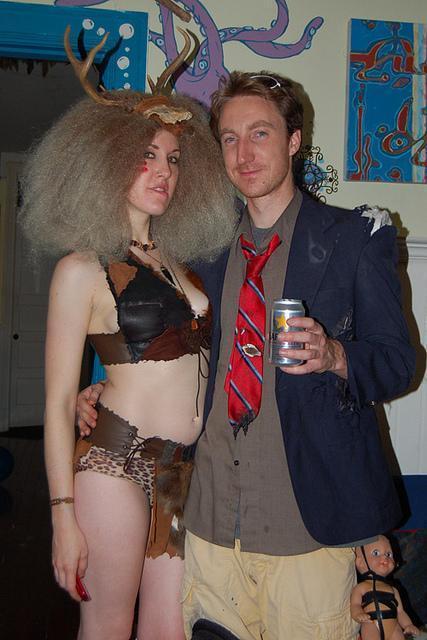How many people are there?
Give a very brief answer. 2. How many toothbrush do you see?
Give a very brief answer. 0. 